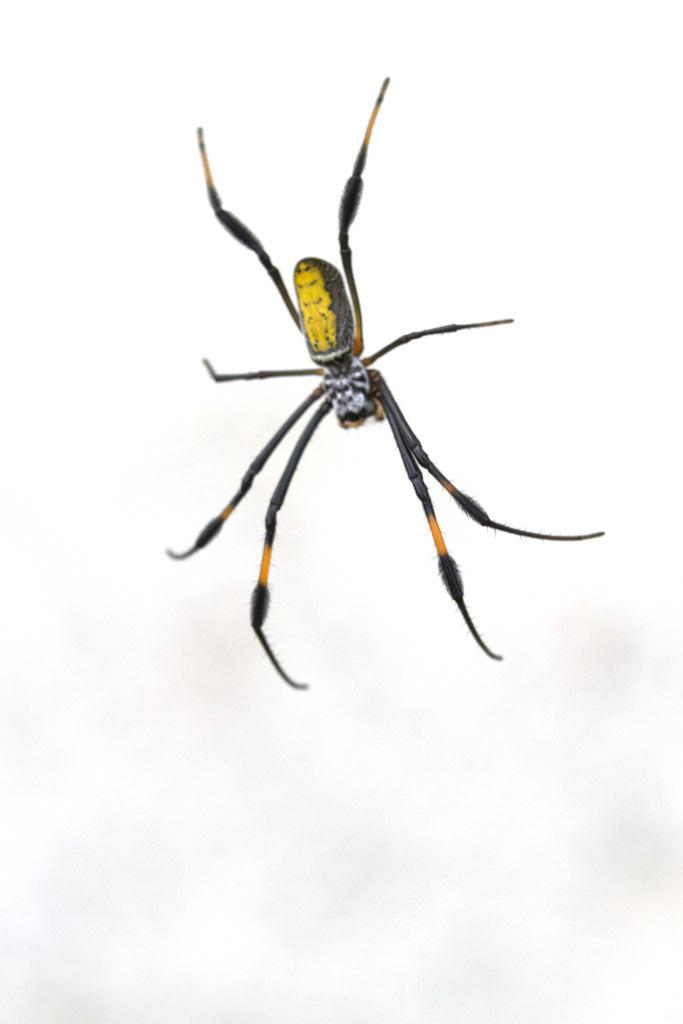What type of creature can be seen in the image? There is an insect in the image. What color is the background of the image? The background of the image is white. How does the rose contribute to the acoustics in the image? There is no rose present in the image, so it cannot contribute to the acoustics. 